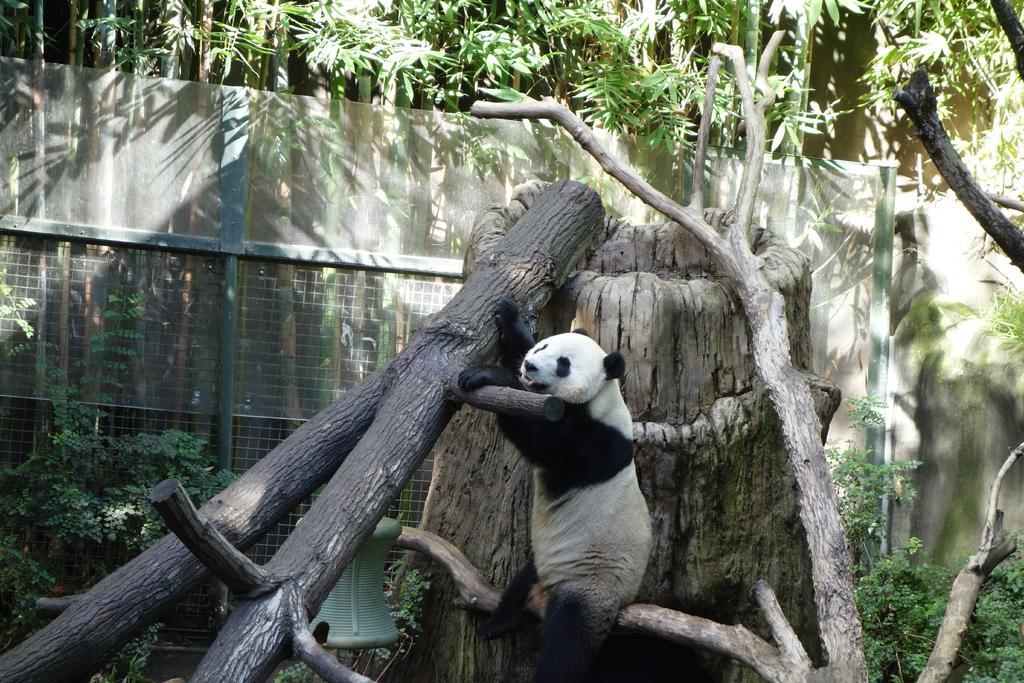In one or two sentences, can you explain what this image depicts? In this picture I can see a panda in the middle, in the background there are trees and I can see the net. 